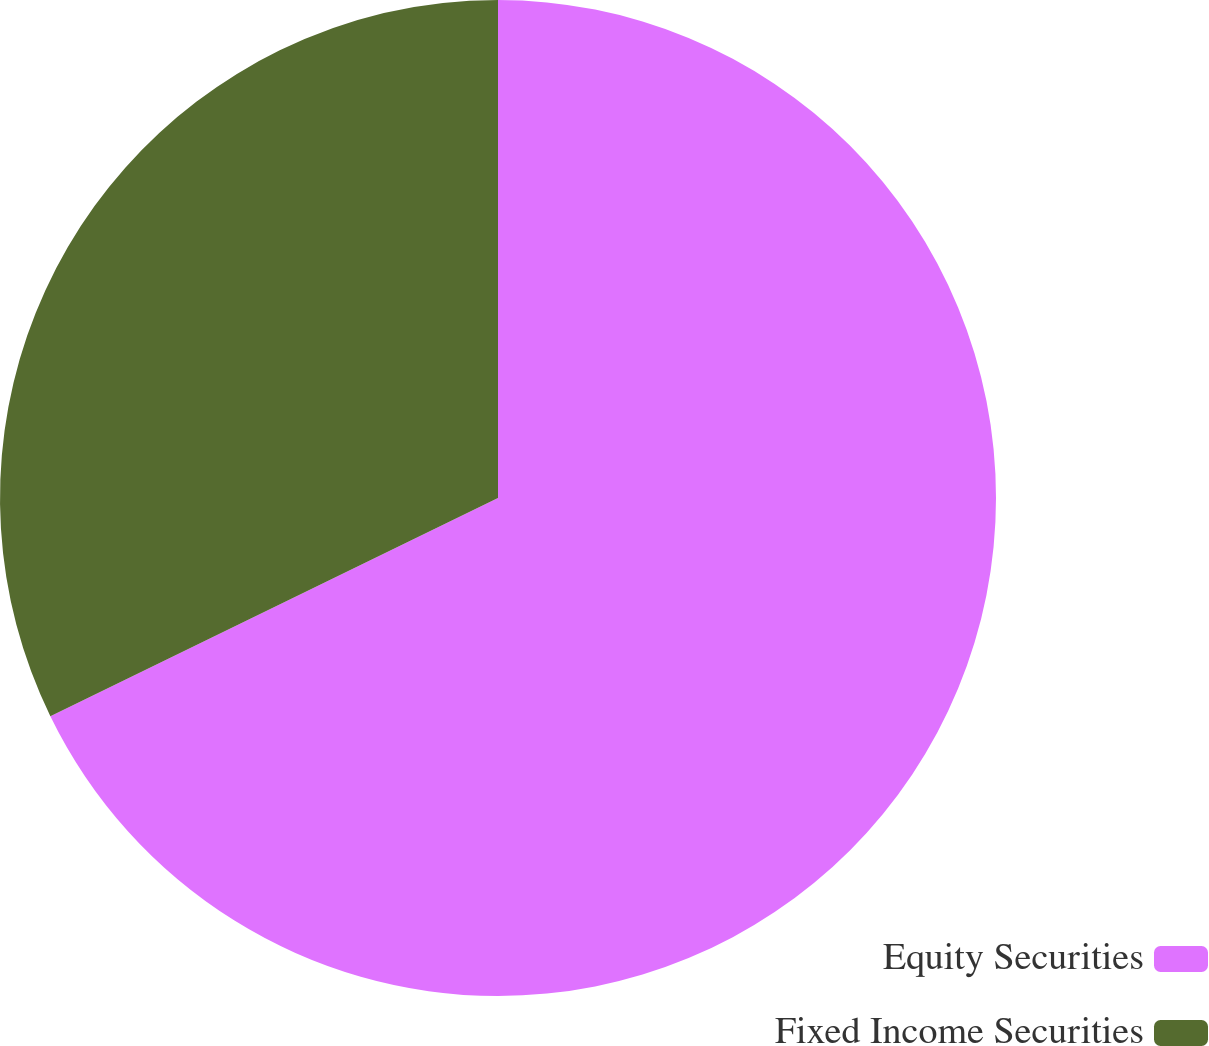<chart> <loc_0><loc_0><loc_500><loc_500><pie_chart><fcel>Equity Securities<fcel>Fixed Income Securities<nl><fcel>67.78%<fcel>32.22%<nl></chart> 